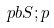<formula> <loc_0><loc_0><loc_500><loc_500>\ p b { S ; p }</formula> 